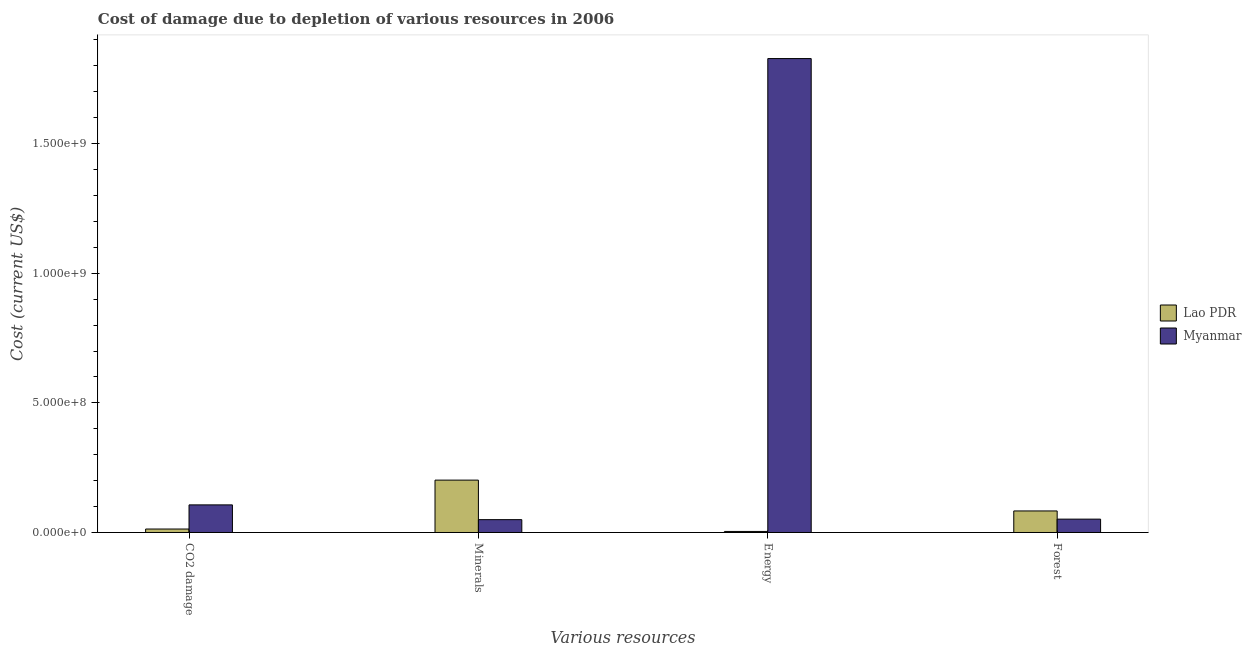How many groups of bars are there?
Your answer should be very brief. 4. Are the number of bars on each tick of the X-axis equal?
Provide a short and direct response. Yes. How many bars are there on the 3rd tick from the left?
Ensure brevity in your answer.  2. What is the label of the 1st group of bars from the left?
Make the answer very short. CO2 damage. What is the cost of damage due to depletion of minerals in Myanmar?
Your response must be concise. 4.95e+07. Across all countries, what is the maximum cost of damage due to depletion of energy?
Give a very brief answer. 1.83e+09. Across all countries, what is the minimum cost of damage due to depletion of forests?
Give a very brief answer. 5.15e+07. In which country was the cost of damage due to depletion of energy maximum?
Make the answer very short. Myanmar. In which country was the cost of damage due to depletion of energy minimum?
Provide a succinct answer. Lao PDR. What is the total cost of damage due to depletion of energy in the graph?
Offer a very short reply. 1.83e+09. What is the difference between the cost of damage due to depletion of minerals in Lao PDR and that in Myanmar?
Offer a terse response. 1.52e+08. What is the difference between the cost of damage due to depletion of forests in Myanmar and the cost of damage due to depletion of energy in Lao PDR?
Offer a very short reply. 4.75e+07. What is the average cost of damage due to depletion of forests per country?
Ensure brevity in your answer.  6.73e+07. What is the difference between the cost of damage due to depletion of coal and cost of damage due to depletion of forests in Lao PDR?
Provide a short and direct response. -6.97e+07. In how many countries, is the cost of damage due to depletion of forests greater than 900000000 US$?
Offer a very short reply. 0. What is the ratio of the cost of damage due to depletion of coal in Myanmar to that in Lao PDR?
Your response must be concise. 7.98. What is the difference between the highest and the second highest cost of damage due to depletion of minerals?
Your answer should be very brief. 1.52e+08. What is the difference between the highest and the lowest cost of damage due to depletion of minerals?
Your answer should be very brief. 1.52e+08. In how many countries, is the cost of damage due to depletion of minerals greater than the average cost of damage due to depletion of minerals taken over all countries?
Your answer should be very brief. 1. Is the sum of the cost of damage due to depletion of forests in Lao PDR and Myanmar greater than the maximum cost of damage due to depletion of minerals across all countries?
Ensure brevity in your answer.  No. What does the 2nd bar from the left in Energy represents?
Offer a terse response. Myanmar. What does the 2nd bar from the right in Forest represents?
Ensure brevity in your answer.  Lao PDR. Is it the case that in every country, the sum of the cost of damage due to depletion of coal and cost of damage due to depletion of minerals is greater than the cost of damage due to depletion of energy?
Your answer should be very brief. No. Are all the bars in the graph horizontal?
Your response must be concise. No. Are the values on the major ticks of Y-axis written in scientific E-notation?
Ensure brevity in your answer.  Yes. Where does the legend appear in the graph?
Keep it short and to the point. Center right. What is the title of the graph?
Your response must be concise. Cost of damage due to depletion of various resources in 2006 . Does "Puerto Rico" appear as one of the legend labels in the graph?
Keep it short and to the point. No. What is the label or title of the X-axis?
Give a very brief answer. Various resources. What is the label or title of the Y-axis?
Provide a succinct answer. Cost (current US$). What is the Cost (current US$) of Lao PDR in CO2 damage?
Provide a succinct answer. 1.33e+07. What is the Cost (current US$) of Myanmar in CO2 damage?
Ensure brevity in your answer.  1.06e+08. What is the Cost (current US$) in Lao PDR in Minerals?
Offer a terse response. 2.02e+08. What is the Cost (current US$) of Myanmar in Minerals?
Offer a terse response. 4.95e+07. What is the Cost (current US$) in Lao PDR in Energy?
Ensure brevity in your answer.  4.01e+06. What is the Cost (current US$) of Myanmar in Energy?
Your answer should be very brief. 1.83e+09. What is the Cost (current US$) of Lao PDR in Forest?
Keep it short and to the point. 8.31e+07. What is the Cost (current US$) of Myanmar in Forest?
Offer a very short reply. 5.15e+07. Across all Various resources, what is the maximum Cost (current US$) of Lao PDR?
Make the answer very short. 2.02e+08. Across all Various resources, what is the maximum Cost (current US$) of Myanmar?
Ensure brevity in your answer.  1.83e+09. Across all Various resources, what is the minimum Cost (current US$) in Lao PDR?
Your answer should be compact. 4.01e+06. Across all Various resources, what is the minimum Cost (current US$) of Myanmar?
Provide a short and direct response. 4.95e+07. What is the total Cost (current US$) in Lao PDR in the graph?
Provide a short and direct response. 3.02e+08. What is the total Cost (current US$) of Myanmar in the graph?
Provide a succinct answer. 2.04e+09. What is the difference between the Cost (current US$) of Lao PDR in CO2 damage and that in Minerals?
Provide a succinct answer. -1.89e+08. What is the difference between the Cost (current US$) of Myanmar in CO2 damage and that in Minerals?
Make the answer very short. 5.69e+07. What is the difference between the Cost (current US$) of Lao PDR in CO2 damage and that in Energy?
Offer a very short reply. 9.34e+06. What is the difference between the Cost (current US$) in Myanmar in CO2 damage and that in Energy?
Make the answer very short. -1.72e+09. What is the difference between the Cost (current US$) in Lao PDR in CO2 damage and that in Forest?
Keep it short and to the point. -6.97e+07. What is the difference between the Cost (current US$) of Myanmar in CO2 damage and that in Forest?
Keep it short and to the point. 5.49e+07. What is the difference between the Cost (current US$) in Lao PDR in Minerals and that in Energy?
Provide a short and direct response. 1.98e+08. What is the difference between the Cost (current US$) in Myanmar in Minerals and that in Energy?
Your answer should be very brief. -1.78e+09. What is the difference between the Cost (current US$) of Lao PDR in Minerals and that in Forest?
Your answer should be compact. 1.19e+08. What is the difference between the Cost (current US$) in Myanmar in Minerals and that in Forest?
Keep it short and to the point. -2.00e+06. What is the difference between the Cost (current US$) of Lao PDR in Energy and that in Forest?
Provide a succinct answer. -7.91e+07. What is the difference between the Cost (current US$) of Myanmar in Energy and that in Forest?
Your answer should be compact. 1.78e+09. What is the difference between the Cost (current US$) in Lao PDR in CO2 damage and the Cost (current US$) in Myanmar in Minerals?
Provide a short and direct response. -3.62e+07. What is the difference between the Cost (current US$) of Lao PDR in CO2 damage and the Cost (current US$) of Myanmar in Energy?
Provide a succinct answer. -1.81e+09. What is the difference between the Cost (current US$) of Lao PDR in CO2 damage and the Cost (current US$) of Myanmar in Forest?
Your answer should be compact. -3.82e+07. What is the difference between the Cost (current US$) in Lao PDR in Minerals and the Cost (current US$) in Myanmar in Energy?
Make the answer very short. -1.63e+09. What is the difference between the Cost (current US$) of Lao PDR in Minerals and the Cost (current US$) of Myanmar in Forest?
Offer a terse response. 1.50e+08. What is the difference between the Cost (current US$) in Lao PDR in Energy and the Cost (current US$) in Myanmar in Forest?
Your response must be concise. -4.75e+07. What is the average Cost (current US$) in Lao PDR per Various resources?
Provide a short and direct response. 7.56e+07. What is the average Cost (current US$) of Myanmar per Various resources?
Your answer should be very brief. 5.09e+08. What is the difference between the Cost (current US$) of Lao PDR and Cost (current US$) of Myanmar in CO2 damage?
Ensure brevity in your answer.  -9.31e+07. What is the difference between the Cost (current US$) of Lao PDR and Cost (current US$) of Myanmar in Minerals?
Provide a succinct answer. 1.52e+08. What is the difference between the Cost (current US$) of Lao PDR and Cost (current US$) of Myanmar in Energy?
Give a very brief answer. -1.82e+09. What is the difference between the Cost (current US$) in Lao PDR and Cost (current US$) in Myanmar in Forest?
Provide a short and direct response. 3.15e+07. What is the ratio of the Cost (current US$) of Lao PDR in CO2 damage to that in Minerals?
Ensure brevity in your answer.  0.07. What is the ratio of the Cost (current US$) of Myanmar in CO2 damage to that in Minerals?
Offer a very short reply. 2.15. What is the ratio of the Cost (current US$) in Lao PDR in CO2 damage to that in Energy?
Your response must be concise. 3.33. What is the ratio of the Cost (current US$) in Myanmar in CO2 damage to that in Energy?
Make the answer very short. 0.06. What is the ratio of the Cost (current US$) in Lao PDR in CO2 damage to that in Forest?
Offer a terse response. 0.16. What is the ratio of the Cost (current US$) in Myanmar in CO2 damage to that in Forest?
Offer a very short reply. 2.07. What is the ratio of the Cost (current US$) of Lao PDR in Minerals to that in Energy?
Your response must be concise. 50.41. What is the ratio of the Cost (current US$) of Myanmar in Minerals to that in Energy?
Make the answer very short. 0.03. What is the ratio of the Cost (current US$) of Lao PDR in Minerals to that in Forest?
Give a very brief answer. 2.43. What is the ratio of the Cost (current US$) in Myanmar in Minerals to that in Forest?
Keep it short and to the point. 0.96. What is the ratio of the Cost (current US$) of Lao PDR in Energy to that in Forest?
Keep it short and to the point. 0.05. What is the ratio of the Cost (current US$) of Myanmar in Energy to that in Forest?
Offer a terse response. 35.47. What is the difference between the highest and the second highest Cost (current US$) in Lao PDR?
Keep it short and to the point. 1.19e+08. What is the difference between the highest and the second highest Cost (current US$) in Myanmar?
Provide a short and direct response. 1.72e+09. What is the difference between the highest and the lowest Cost (current US$) of Lao PDR?
Your answer should be compact. 1.98e+08. What is the difference between the highest and the lowest Cost (current US$) of Myanmar?
Ensure brevity in your answer.  1.78e+09. 